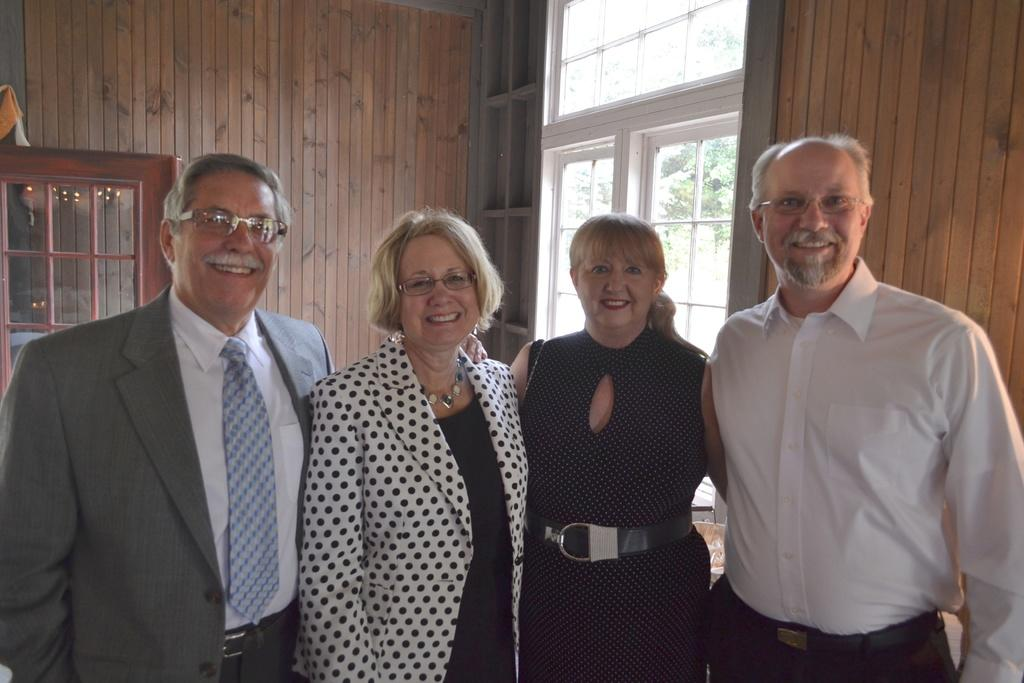What is happening in the image involving the group of people? The people in the image are smiling. Can you describe any specific features of the people in the group? Some people in the group are wearing spectacles. What can be seen in the background of the image? There are windows and trees visible in the background of the image. What type of bread can be seen in the alley in the image? There is no bread or alley present in the image; it features a group of people and a background with windows and trees. 